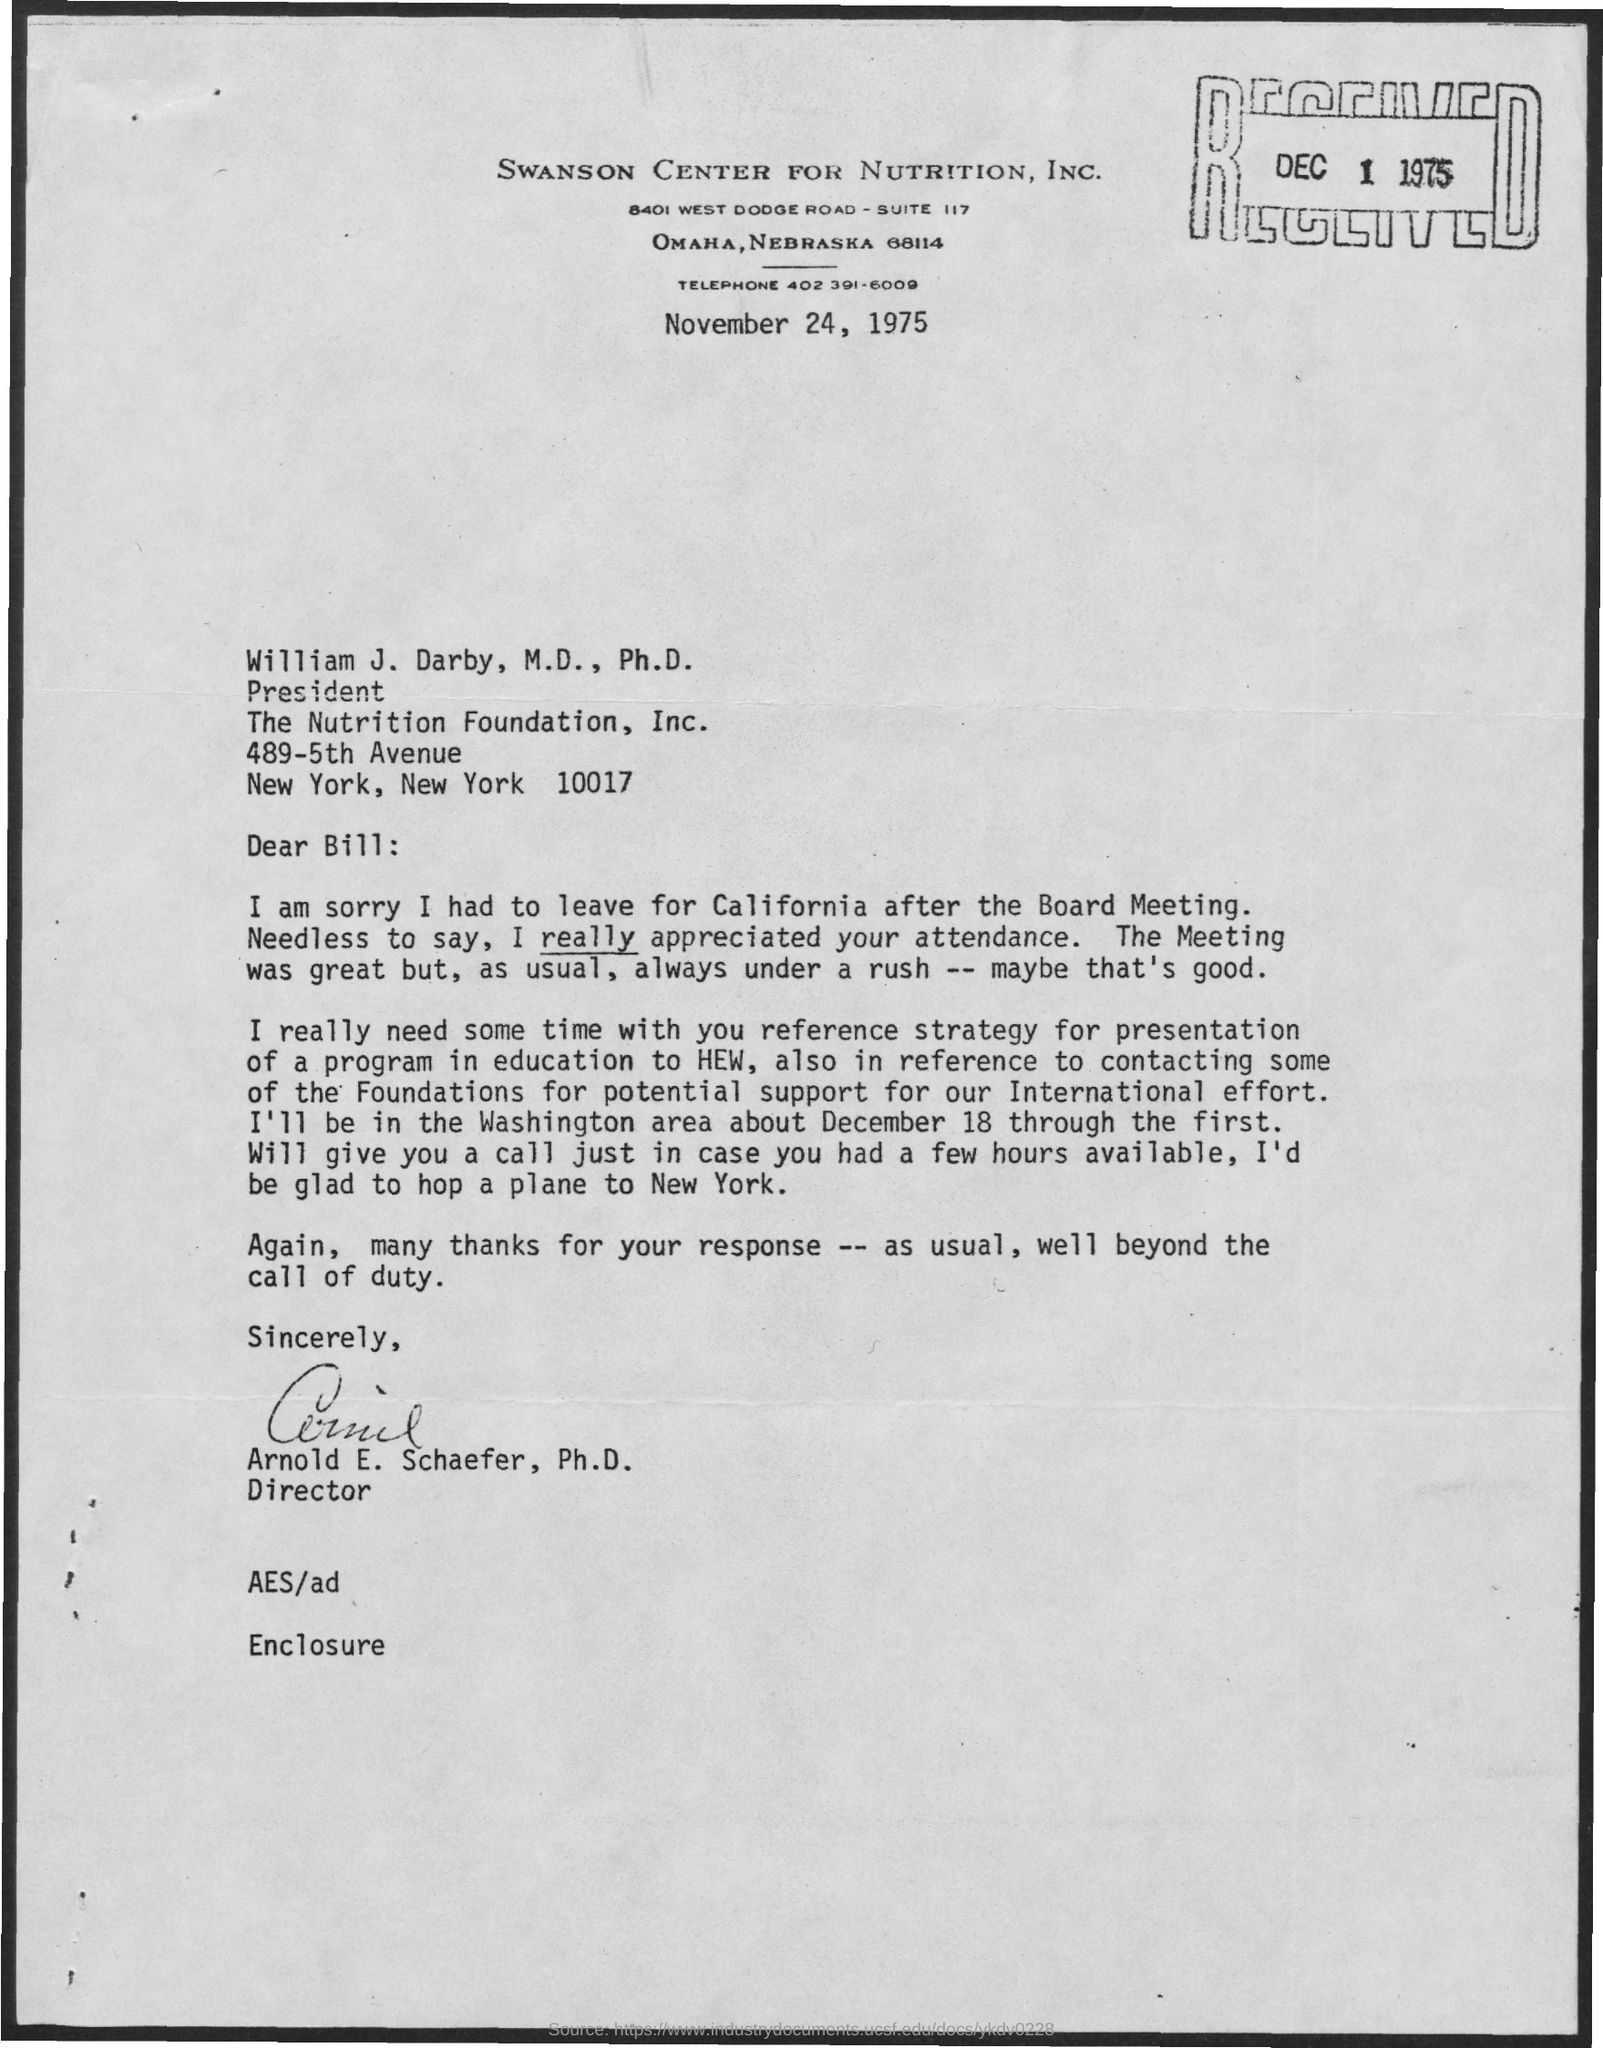Draw attention to some important aspects in this diagram. The telephone number is 402 391-6009. The suit number is 117. 